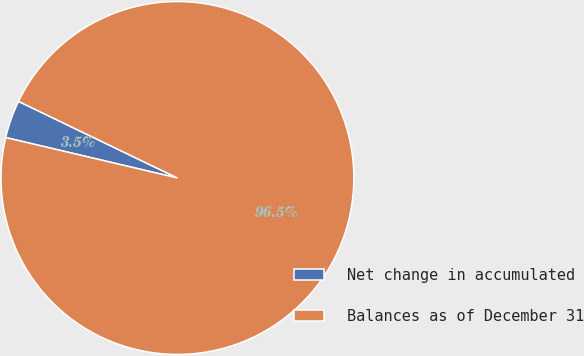<chart> <loc_0><loc_0><loc_500><loc_500><pie_chart><fcel>Net change in accumulated<fcel>Balances as of December 31<nl><fcel>3.47%<fcel>96.53%<nl></chart> 